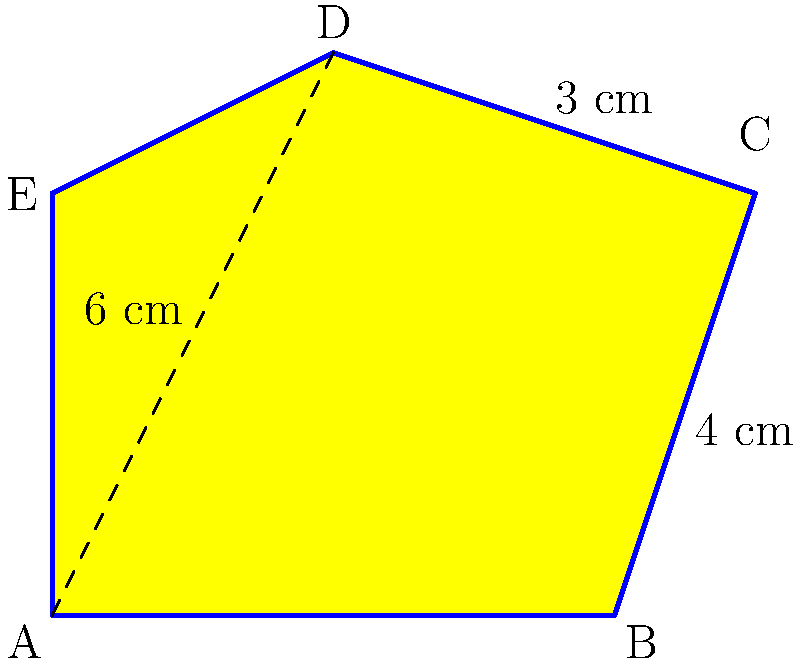L-l-look at this c-colorful kite! Can you h-help me f-find its area? The d-diagonal from A to D is 6 cm, and the other p-parts are 4 cm and 3 cm as sh-shown. Let's break this down step-by-step:

1) The kite is made up of two triangles. We can find the area of the whole kite by adding the areas of these two triangles.

2) For each triangle, we can use the formula: 
   Area of triangle = $\frac{1}{2} \times$ base $\times$ height

3) The diagonal AD (6 cm) acts as the base for both triangles.

4) The other measurements (4 cm and 3 cm) are the heights of these triangles.

5) For the first triangle:
   Area = $\frac{1}{2} \times 6 \times 4 = 12$ sq cm

6) For the second triangle:
   Area = $\frac{1}{2} \times 6 \times 3 = 9$ sq cm

7) Total area of the kite:
   $12 + 9 = 21$ sq cm

Therefore, the area of the kite is 21 square centimeters.
Answer: 21 sq cm 